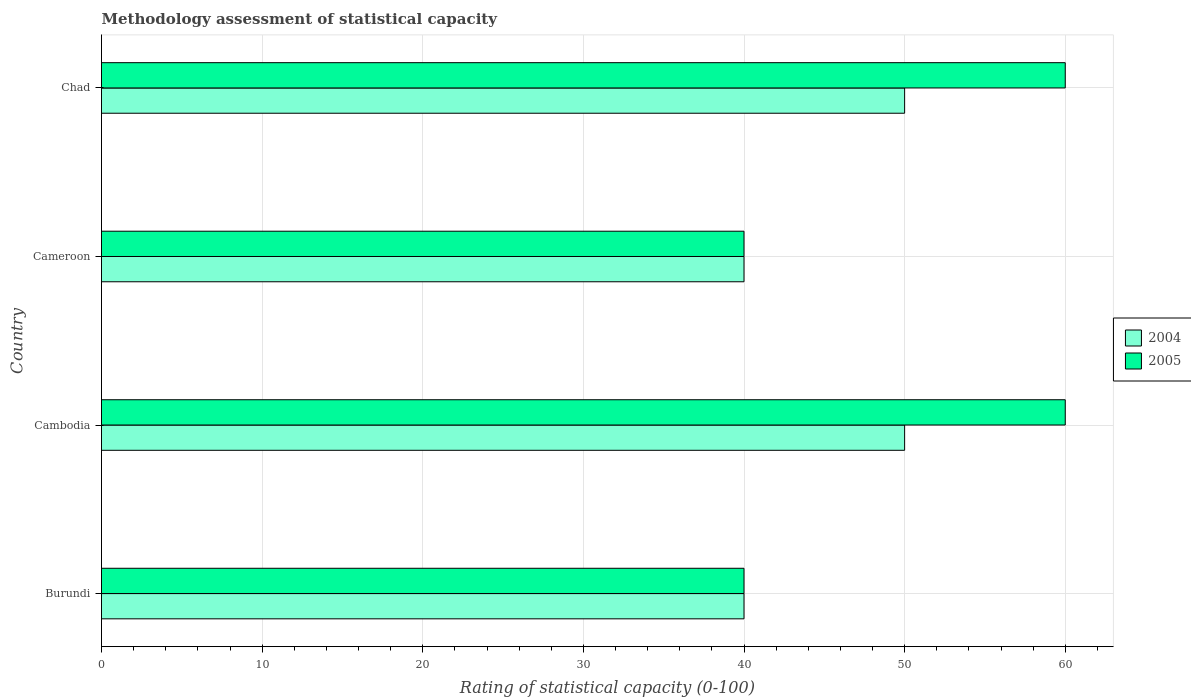Are the number of bars per tick equal to the number of legend labels?
Offer a terse response. Yes. What is the label of the 4th group of bars from the top?
Your answer should be very brief. Burundi. What is the rating of statistical capacity in 2005 in Burundi?
Offer a terse response. 40. Across all countries, what is the maximum rating of statistical capacity in 2005?
Keep it short and to the point. 60. In which country was the rating of statistical capacity in 2004 maximum?
Provide a succinct answer. Cambodia. In which country was the rating of statistical capacity in 2005 minimum?
Give a very brief answer. Burundi. What is the total rating of statistical capacity in 2004 in the graph?
Your answer should be very brief. 180. What is the difference between the rating of statistical capacity in 2004 in Burundi and that in Cameroon?
Offer a very short reply. 0. What is the difference between the rating of statistical capacity in 2005 and rating of statistical capacity in 2004 in Burundi?
Provide a succinct answer. 0. In how many countries, is the rating of statistical capacity in 2004 greater than 10 ?
Give a very brief answer. 4. What is the ratio of the rating of statistical capacity in 2005 in Cambodia to that in Chad?
Ensure brevity in your answer.  1. Is the rating of statistical capacity in 2005 in Burundi less than that in Cameroon?
Ensure brevity in your answer.  No. Is the difference between the rating of statistical capacity in 2005 in Burundi and Cambodia greater than the difference between the rating of statistical capacity in 2004 in Burundi and Cambodia?
Ensure brevity in your answer.  No. In how many countries, is the rating of statistical capacity in 2005 greater than the average rating of statistical capacity in 2005 taken over all countries?
Your response must be concise. 2. What does the 1st bar from the top in Chad represents?
Make the answer very short. 2005. Are all the bars in the graph horizontal?
Provide a succinct answer. Yes. How many countries are there in the graph?
Your answer should be compact. 4. What is the difference between two consecutive major ticks on the X-axis?
Your response must be concise. 10. Where does the legend appear in the graph?
Your answer should be very brief. Center right. What is the title of the graph?
Provide a short and direct response. Methodology assessment of statistical capacity. Does "1964" appear as one of the legend labels in the graph?
Offer a terse response. No. What is the label or title of the X-axis?
Ensure brevity in your answer.  Rating of statistical capacity (0-100). What is the label or title of the Y-axis?
Ensure brevity in your answer.  Country. What is the Rating of statistical capacity (0-100) of 2005 in Cambodia?
Your answer should be compact. 60. What is the Rating of statistical capacity (0-100) in 2005 in Cameroon?
Keep it short and to the point. 40. What is the Rating of statistical capacity (0-100) in 2004 in Chad?
Offer a very short reply. 50. Across all countries, what is the maximum Rating of statistical capacity (0-100) of 2005?
Offer a very short reply. 60. Across all countries, what is the minimum Rating of statistical capacity (0-100) of 2005?
Keep it short and to the point. 40. What is the total Rating of statistical capacity (0-100) of 2004 in the graph?
Your answer should be very brief. 180. What is the difference between the Rating of statistical capacity (0-100) in 2005 in Burundi and that in Cambodia?
Ensure brevity in your answer.  -20. What is the difference between the Rating of statistical capacity (0-100) in 2004 in Burundi and that in Cameroon?
Your answer should be very brief. 0. What is the difference between the Rating of statistical capacity (0-100) in 2005 in Burundi and that in Cameroon?
Provide a short and direct response. 0. What is the difference between the Rating of statistical capacity (0-100) in 2004 in Burundi and that in Chad?
Your response must be concise. -10. What is the difference between the Rating of statistical capacity (0-100) of 2005 in Burundi and that in Chad?
Offer a terse response. -20. What is the difference between the Rating of statistical capacity (0-100) of 2004 in Cambodia and that in Cameroon?
Offer a terse response. 10. What is the difference between the Rating of statistical capacity (0-100) in 2005 in Cambodia and that in Cameroon?
Your answer should be very brief. 20. What is the difference between the Rating of statistical capacity (0-100) in 2005 in Cambodia and that in Chad?
Offer a terse response. 0. What is the difference between the Rating of statistical capacity (0-100) in 2004 in Cameroon and that in Chad?
Your answer should be compact. -10. What is the difference between the Rating of statistical capacity (0-100) of 2005 in Cameroon and that in Chad?
Ensure brevity in your answer.  -20. What is the difference between the Rating of statistical capacity (0-100) in 2004 in Burundi and the Rating of statistical capacity (0-100) in 2005 in Chad?
Keep it short and to the point. -20. What is the difference between the Rating of statistical capacity (0-100) in 2004 in Cambodia and the Rating of statistical capacity (0-100) in 2005 in Cameroon?
Give a very brief answer. 10. What is the difference between the Rating of statistical capacity (0-100) of 2004 in Cambodia and the Rating of statistical capacity (0-100) of 2005 in Chad?
Provide a succinct answer. -10. What is the difference between the Rating of statistical capacity (0-100) of 2004 in Cameroon and the Rating of statistical capacity (0-100) of 2005 in Chad?
Offer a terse response. -20. What is the average Rating of statistical capacity (0-100) in 2004 per country?
Your response must be concise. 45. What is the average Rating of statistical capacity (0-100) in 2005 per country?
Your answer should be very brief. 50. What is the difference between the Rating of statistical capacity (0-100) in 2004 and Rating of statistical capacity (0-100) in 2005 in Burundi?
Keep it short and to the point. 0. What is the difference between the Rating of statistical capacity (0-100) in 2004 and Rating of statistical capacity (0-100) in 2005 in Chad?
Provide a short and direct response. -10. What is the ratio of the Rating of statistical capacity (0-100) in 2004 in Burundi to that in Cameroon?
Offer a terse response. 1. What is the ratio of the Rating of statistical capacity (0-100) of 2004 in Burundi to that in Chad?
Ensure brevity in your answer.  0.8. What is the ratio of the Rating of statistical capacity (0-100) in 2005 in Burundi to that in Chad?
Your response must be concise. 0.67. What is the ratio of the Rating of statistical capacity (0-100) in 2005 in Cambodia to that in Cameroon?
Your response must be concise. 1.5. What is the ratio of the Rating of statistical capacity (0-100) in 2004 in Cambodia to that in Chad?
Make the answer very short. 1. What is the ratio of the Rating of statistical capacity (0-100) of 2004 in Cameroon to that in Chad?
Your answer should be very brief. 0.8. What is the ratio of the Rating of statistical capacity (0-100) of 2005 in Cameroon to that in Chad?
Provide a short and direct response. 0.67. What is the difference between the highest and the second highest Rating of statistical capacity (0-100) in 2004?
Your answer should be very brief. 0. What is the difference between the highest and the lowest Rating of statistical capacity (0-100) of 2005?
Offer a terse response. 20. 